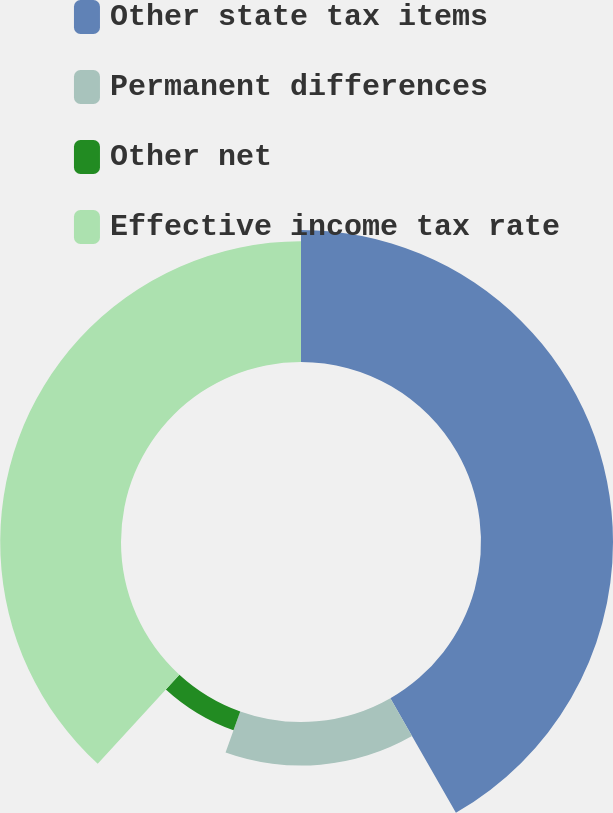Convert chart. <chart><loc_0><loc_0><loc_500><loc_500><pie_chart><fcel>Other state tax items<fcel>Permanent differences<fcel>Other net<fcel>Effective income tax rate<nl><fcel>41.73%<fcel>13.75%<fcel>6.33%<fcel>38.19%<nl></chart> 